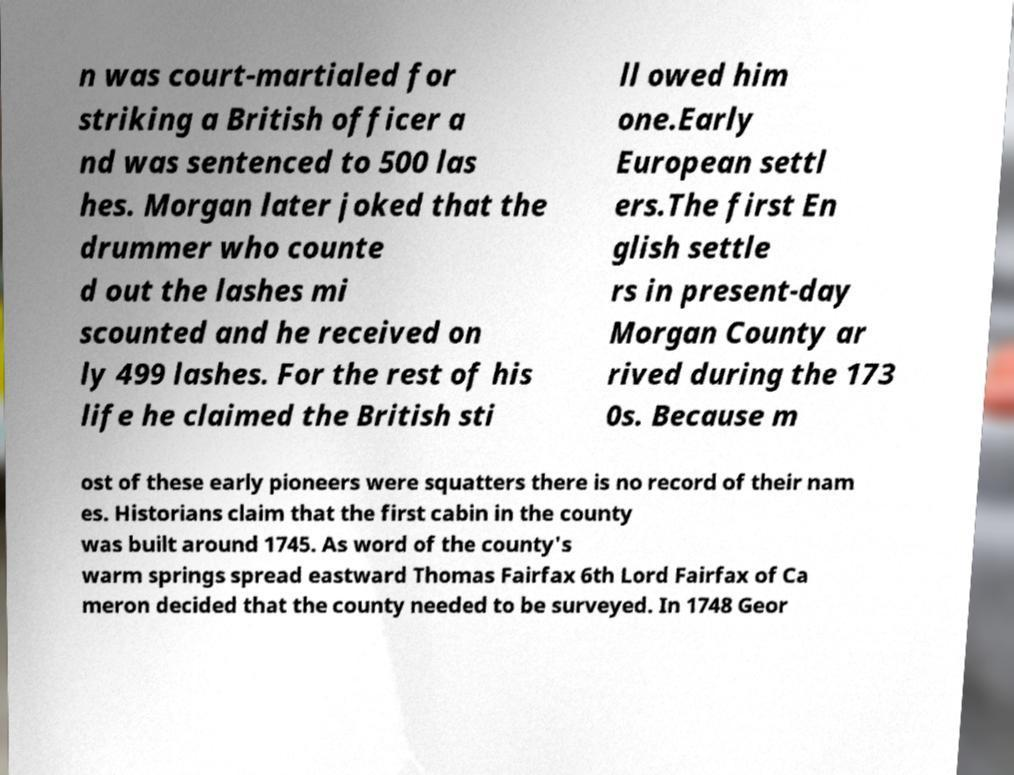I need the written content from this picture converted into text. Can you do that? n was court-martialed for striking a British officer a nd was sentenced to 500 las hes. Morgan later joked that the drummer who counte d out the lashes mi scounted and he received on ly 499 lashes. For the rest of his life he claimed the British sti ll owed him one.Early European settl ers.The first En glish settle rs in present-day Morgan County ar rived during the 173 0s. Because m ost of these early pioneers were squatters there is no record of their nam es. Historians claim that the first cabin in the county was built around 1745. As word of the county's warm springs spread eastward Thomas Fairfax 6th Lord Fairfax of Ca meron decided that the county needed to be surveyed. In 1748 Geor 